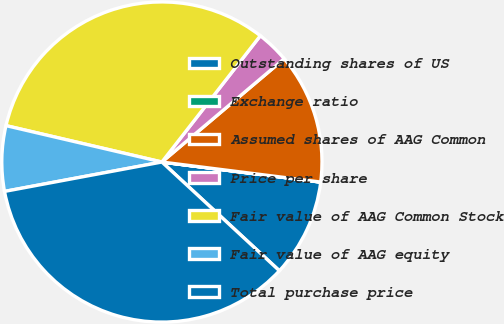Convert chart. <chart><loc_0><loc_0><loc_500><loc_500><pie_chart><fcel>Outstanding shares of US<fcel>Exchange ratio<fcel>Assumed shares of AAG Common<fcel>Price per share<fcel>Fair value of AAG Common Stock<fcel>Fair value of AAG equity<fcel>Total purchase price<nl><fcel>9.88%<fcel>0.01%<fcel>13.16%<fcel>3.3%<fcel>31.89%<fcel>6.59%<fcel>35.18%<nl></chart> 